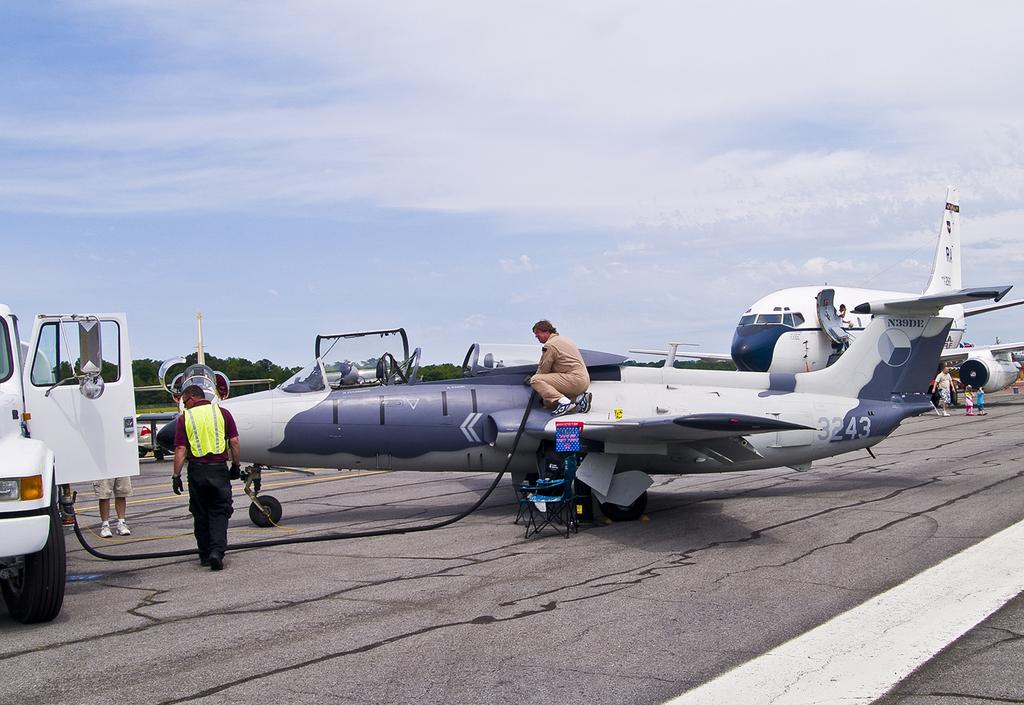What is happening on the left side of the image? There is a man walking on the left side of the image. What can be seen in the sky in the image? The sky is blue in the image. What is the color of the airplane in the image? The airplane is white in color. Can you describe the airplane in the image? The airplane is white and can be seen in the image. What time of day is the event taking place in the image? There is no event mentioned in the image, and the time of day cannot be determined from the provided facts. What idea does the man walking on the left side of the image have? There is no indication of the man's thoughts or ideas in the image. 